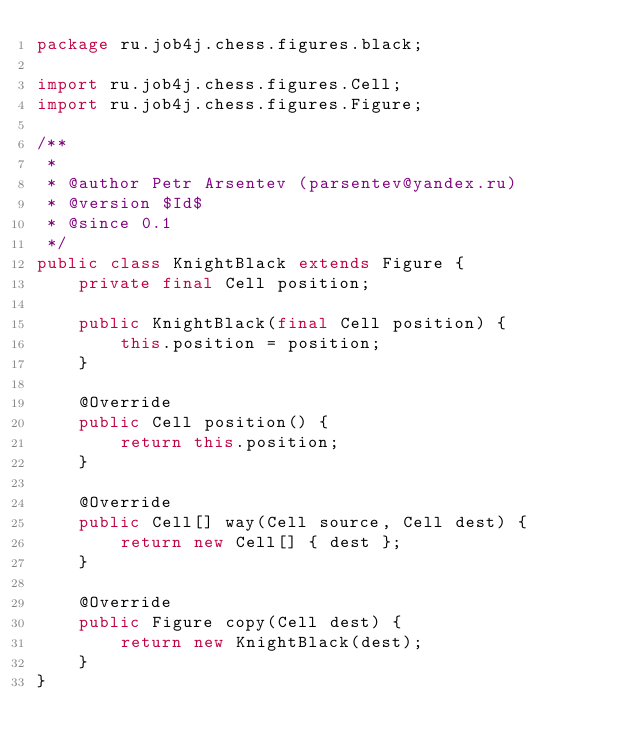<code> <loc_0><loc_0><loc_500><loc_500><_Java_>package ru.job4j.chess.figures.black;

import ru.job4j.chess.figures.Cell;
import ru.job4j.chess.figures.Figure;

/**
 *
 * @author Petr Arsentev (parsentev@yandex.ru)
 * @version $Id$
 * @since 0.1
 */
public class KnightBlack extends Figure {
    private final Cell position;

    public KnightBlack(final Cell position) {
        this.position = position;
    }

    @Override
    public Cell position() {
        return this.position;
    }

    @Override
    public Cell[] way(Cell source, Cell dest) {
        return new Cell[] { dest };
    }

    @Override
    public Figure copy(Cell dest) {
        return new KnightBlack(dest);
    }
}
</code> 